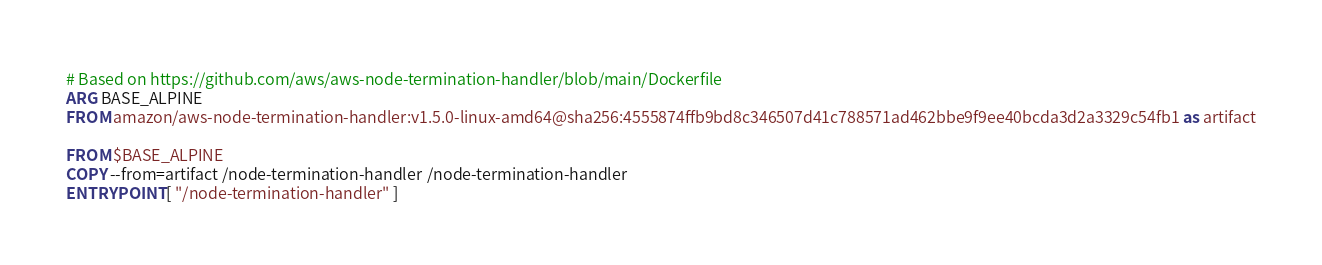<code> <loc_0><loc_0><loc_500><loc_500><_Dockerfile_># Based on https://github.com/aws/aws-node-termination-handler/blob/main/Dockerfile
ARG BASE_ALPINE
FROM amazon/aws-node-termination-handler:v1.5.0-linux-amd64@sha256:4555874ffb9bd8c346507d41c788571ad462bbe9f9ee40bcda3d2a3329c54fb1 as artifact

FROM $BASE_ALPINE
COPY --from=artifact /node-termination-handler /node-termination-handler
ENTRYPOINT [ "/node-termination-handler" ]
</code> 